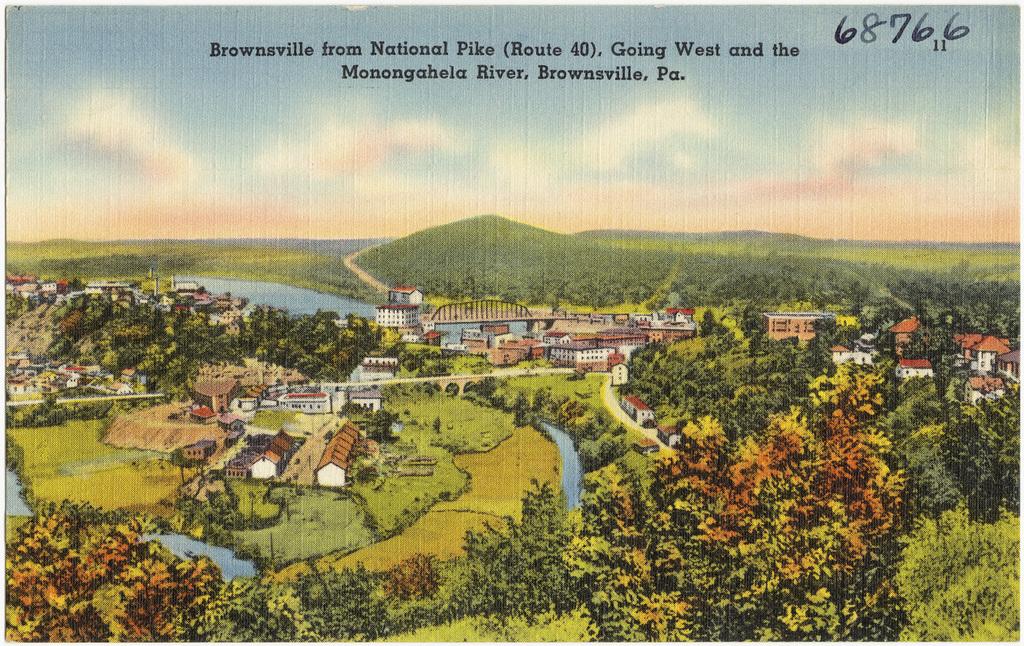Where does this picture represent?
Your response must be concise. Brownsville. What number is on the postcard?
Give a very brief answer. 68766. 